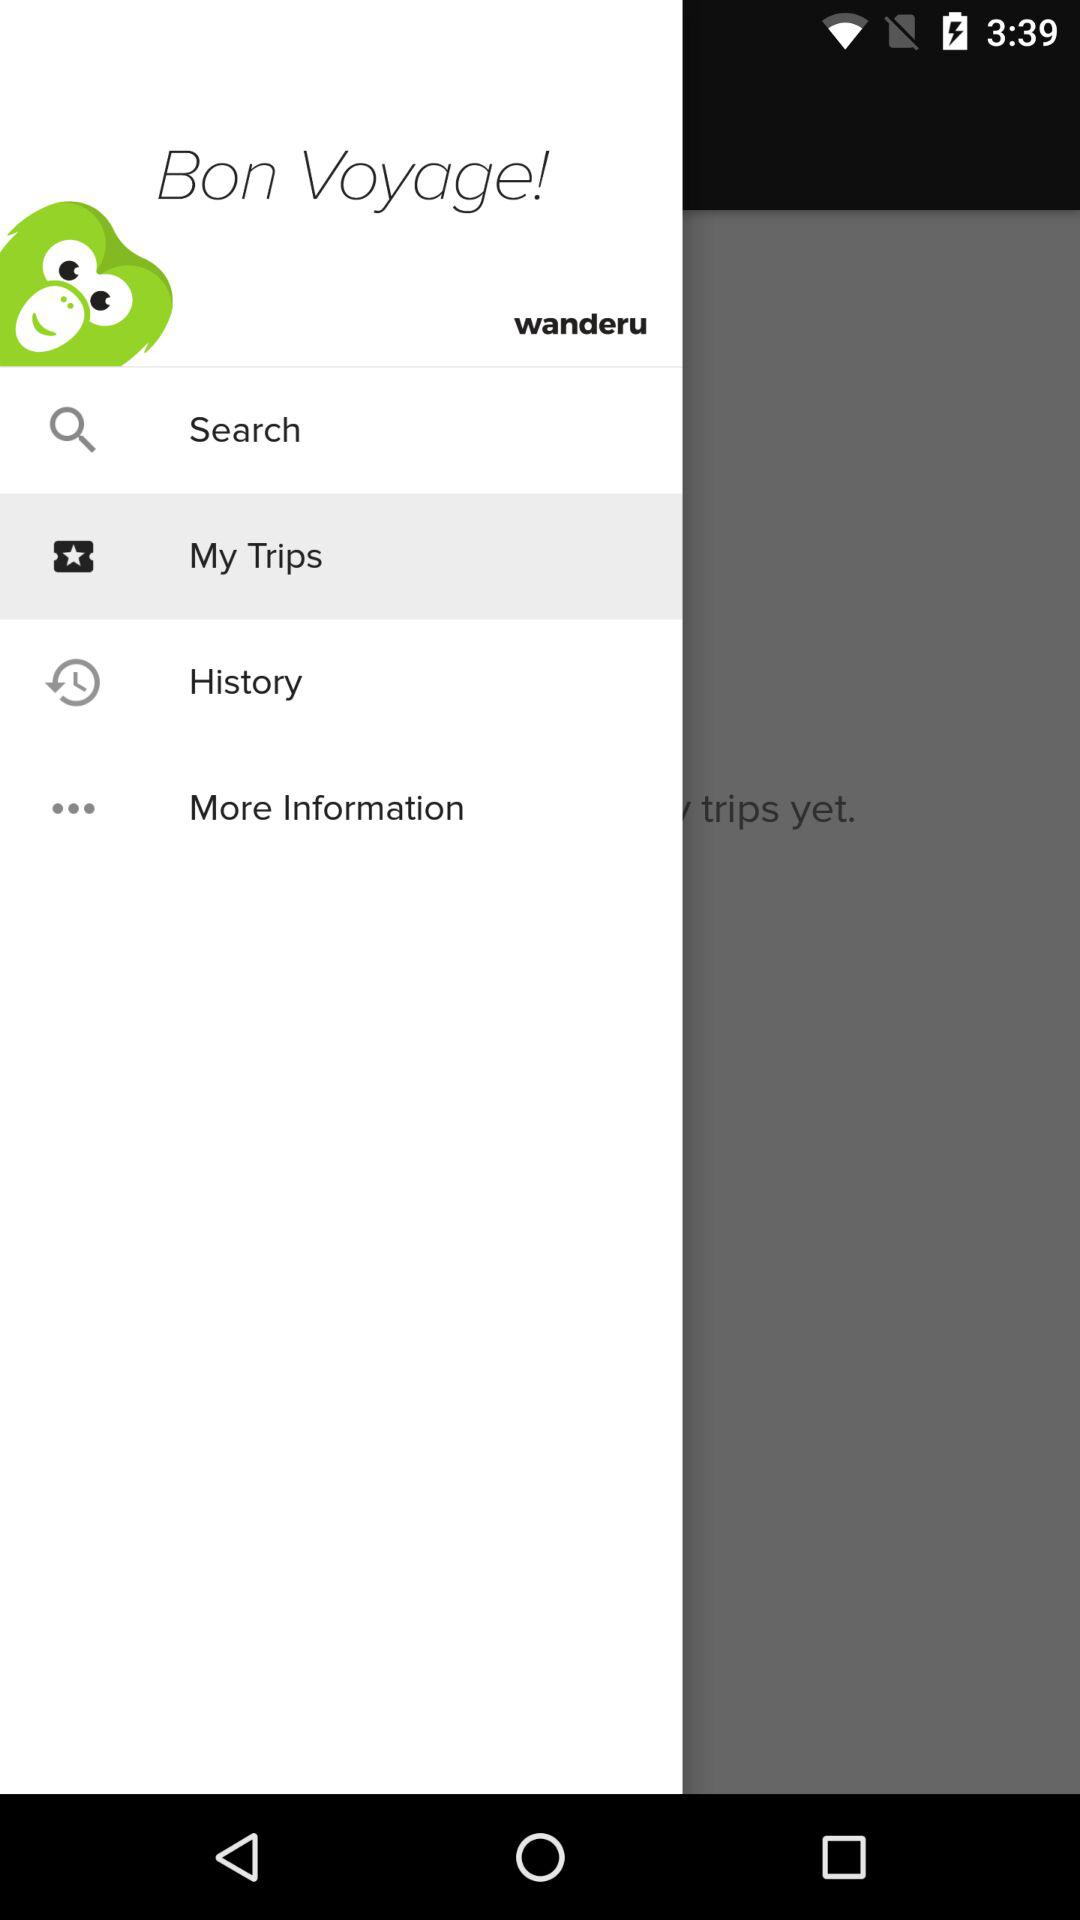What is the selection option? The selected option is "My Trips". 